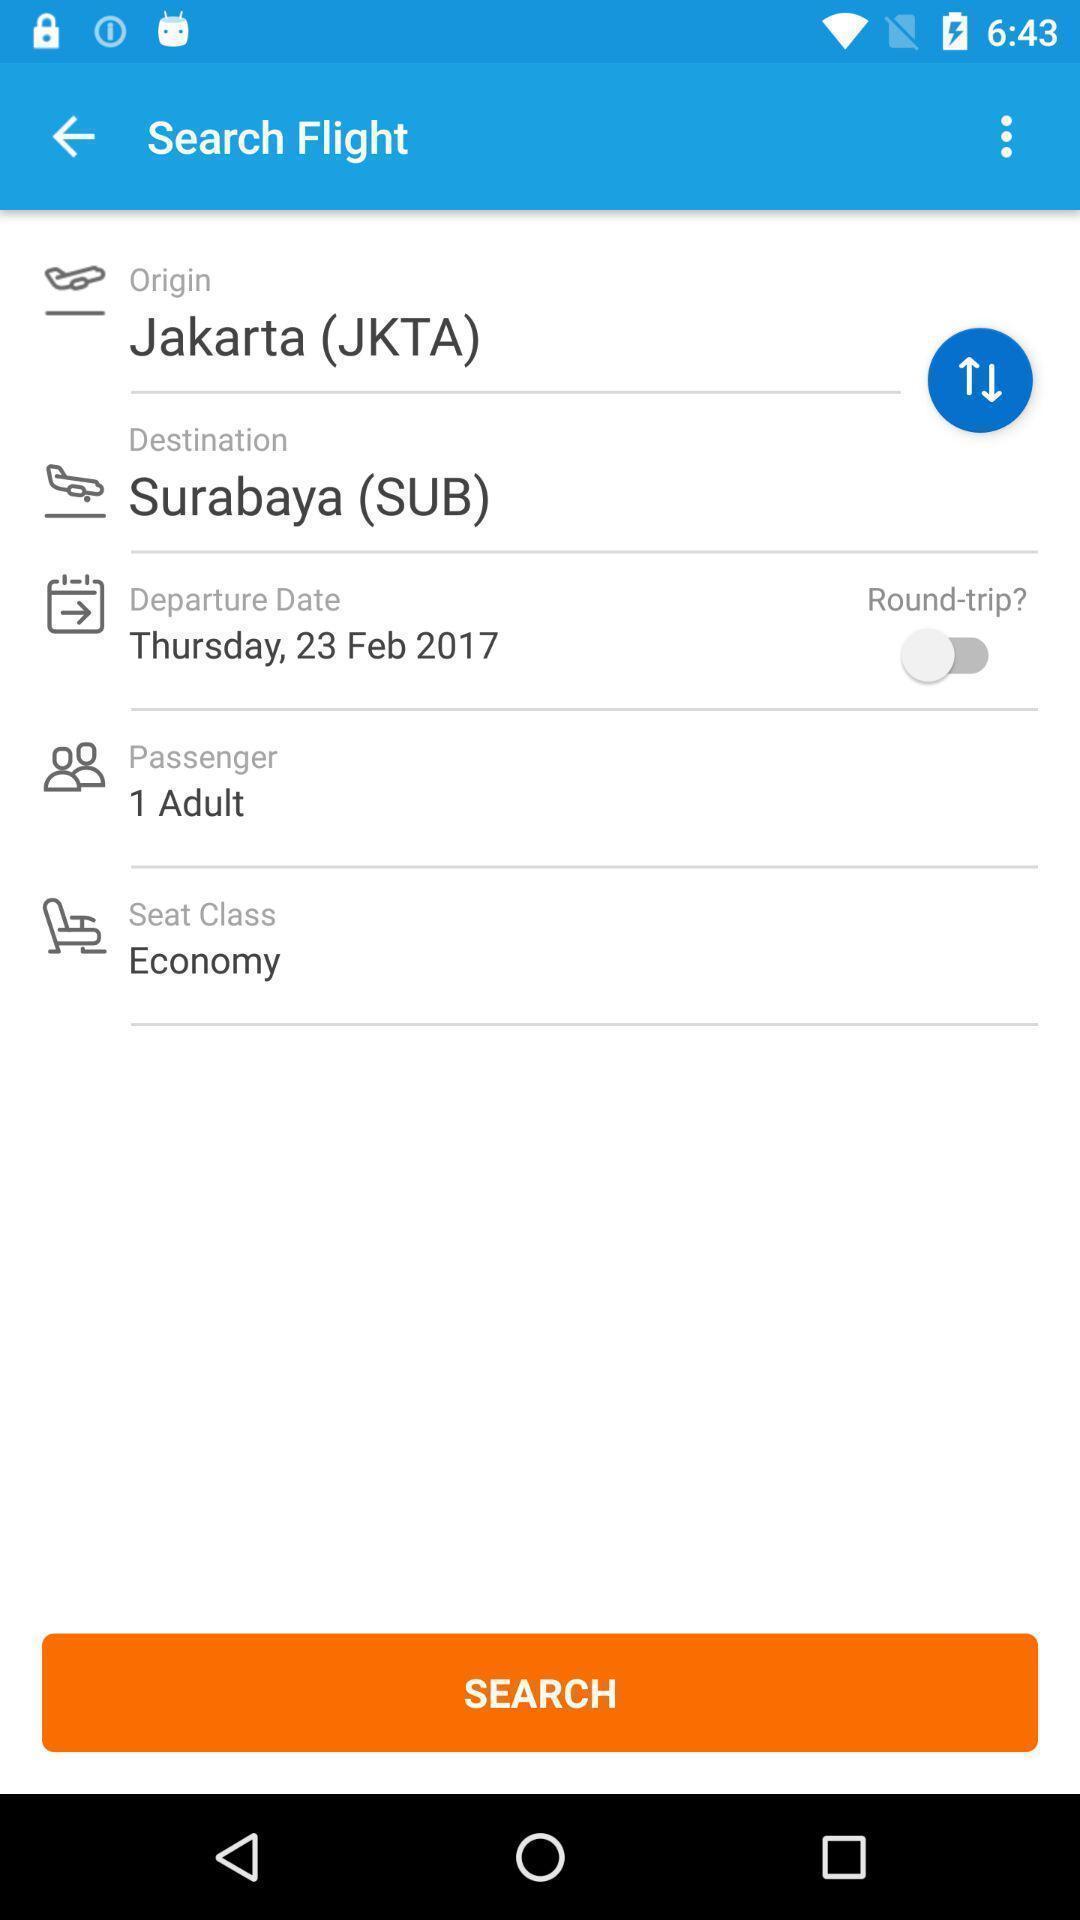Describe the visual elements of this screenshot. Page for searching the flight with desired details. 